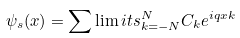<formula> <loc_0><loc_0><loc_500><loc_500>\psi _ { s } ( x ) = \sum \lim i t s _ { k = - N } ^ { N } C _ { k } e ^ { i q x k }</formula> 